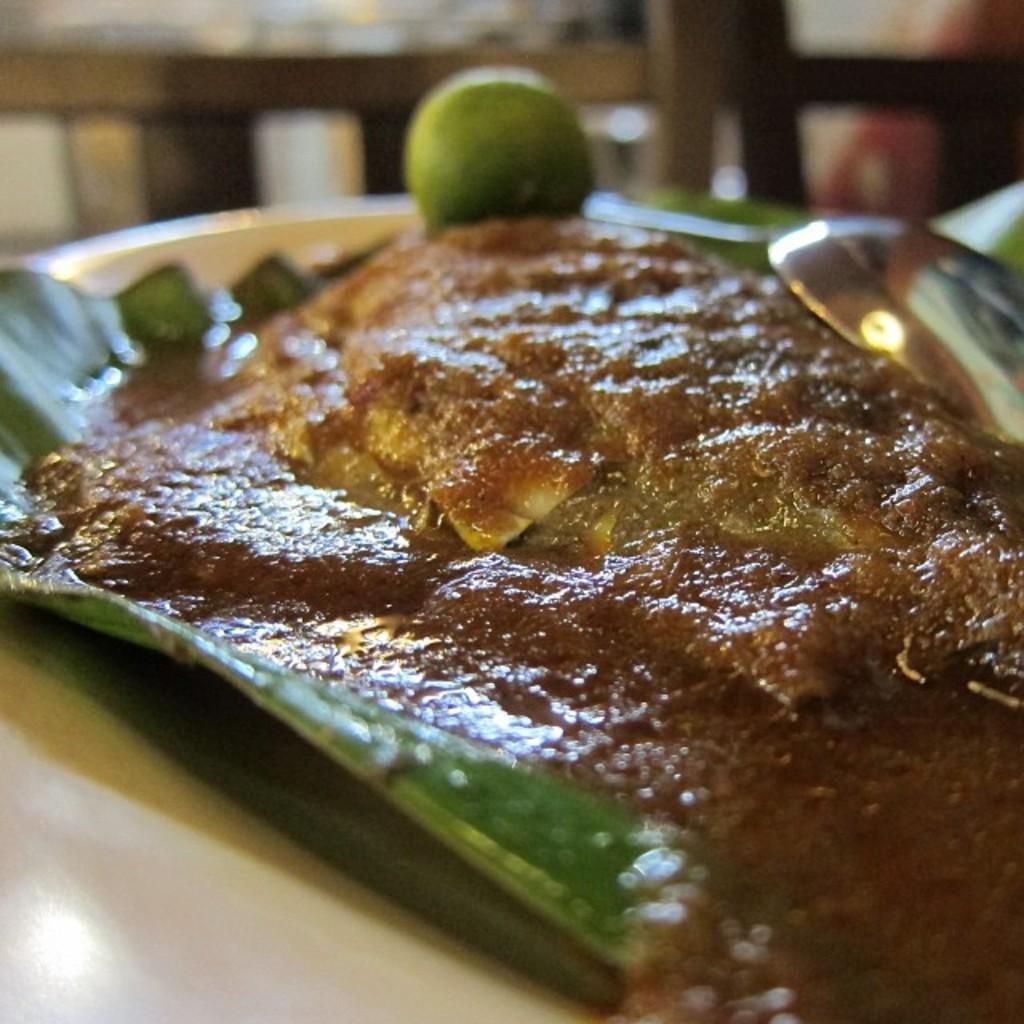Could you give a brief overview of what you see in this image? In the given image i can see a food item in the plate included with spoon. 